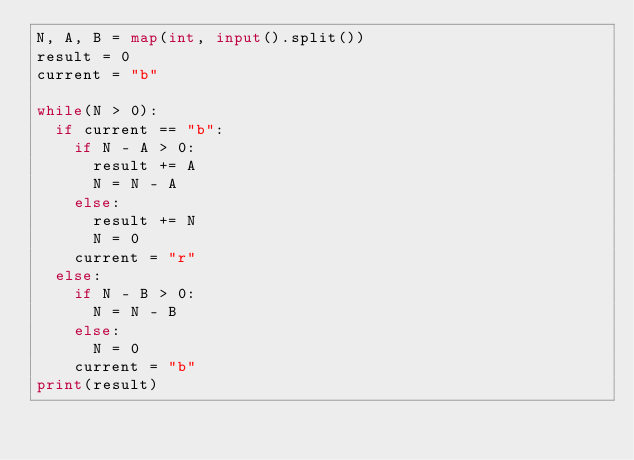Convert code to text. <code><loc_0><loc_0><loc_500><loc_500><_Python_>N, A, B = map(int, input().split())
result = 0
current = "b"

while(N > 0):
  if current == "b":
    if N - A > 0:
      result += A
      N = N - A
    else:
      result += N
      N = 0
    current = "r"
  else:
    if N - B > 0:
      N = N - B
    else:
      N = 0
    current = "b"
print(result)</code> 